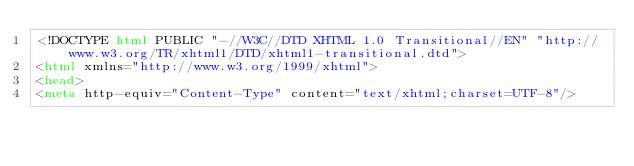Convert code to text. <code><loc_0><loc_0><loc_500><loc_500><_HTML_><!DOCTYPE html PUBLIC "-//W3C//DTD XHTML 1.0 Transitional//EN" "http://www.w3.org/TR/xhtml1/DTD/xhtml1-transitional.dtd">
<html xmlns="http://www.w3.org/1999/xhtml">
<head>
<meta http-equiv="Content-Type" content="text/xhtml;charset=UTF-8"/></code> 